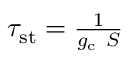Convert formula to latex. <formula><loc_0><loc_0><loc_500><loc_500>\begin{array} { r } { \tau _ { s t } = \frac { 1 } { g _ { c } \ S } } \end{array}</formula> 